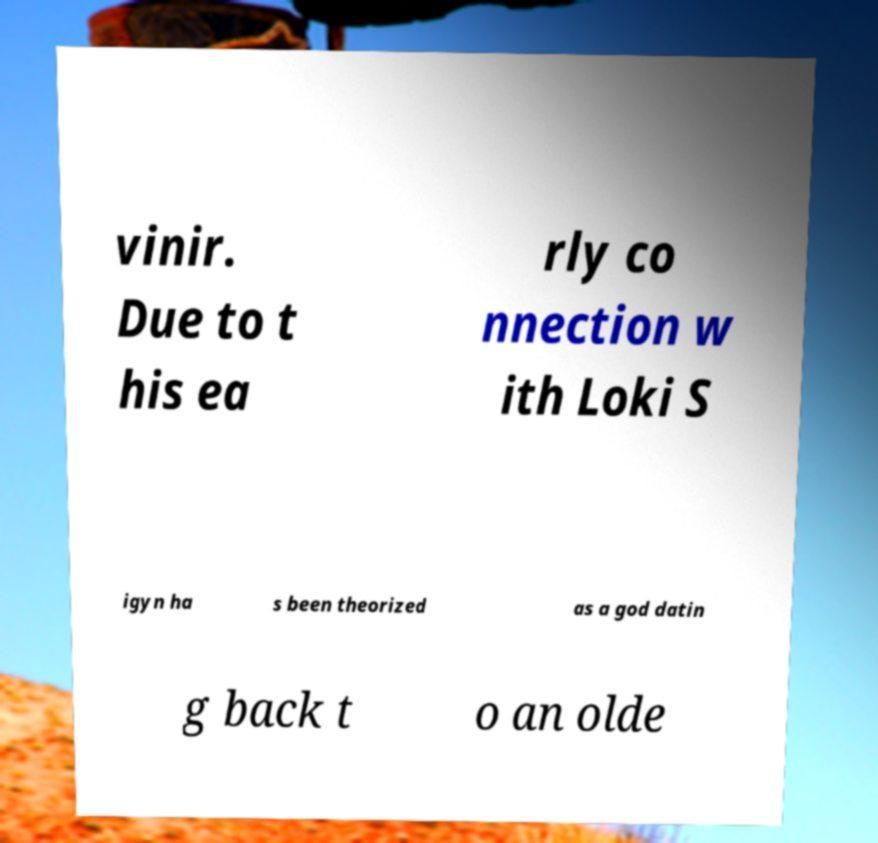There's text embedded in this image that I need extracted. Can you transcribe it verbatim? vinir. Due to t his ea rly co nnection w ith Loki S igyn ha s been theorized as a god datin g back t o an olde 